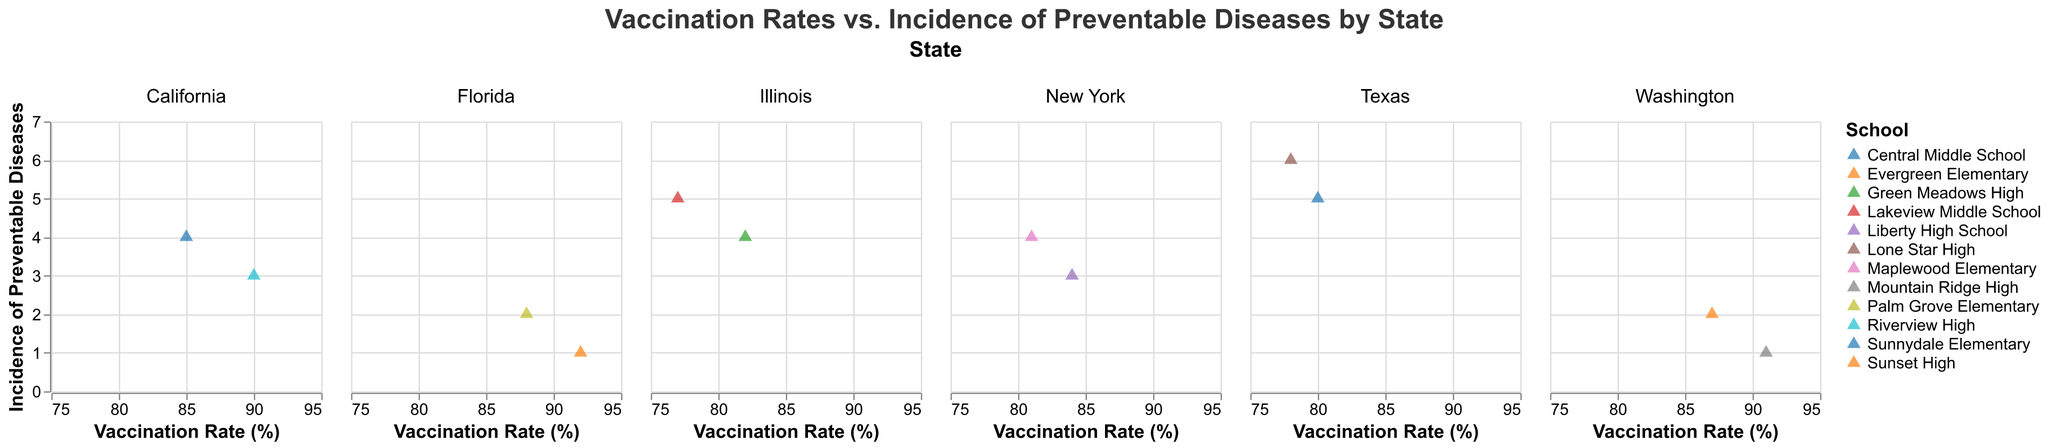What is the title of the chart? The title is usually placed at the top of the chart. Here, you can see it directly under the subtitle bar.
Answer: Vaccination Rates vs. Incidence of Preventable Diseases by State What are the axes labels? The x-axis and y-axis labels are placed at the bottom and the left side of the chart, respectively. The x-axis is labeled "Vaccination Rate (%)" and the y-axis is labeled "Incidence of Preventable Diseases".
Answer: Vaccination Rate (%) and Incidence of Preventable Diseases Which school in California has the highest vaccination rate? Look at the subplot for California and find the data point with the highest x-value (Vaccination Rate). The school associated with this point is Riverview High, with a vaccination rate of 90%.
Answer: Riverview High Compare the incidence of preventable diseases in Evergreen Elementary and Mountain Ridge High in Washington. In the Washington subplot, locate the points for Evergreen Elementary and Mountain Ridge High. Mountain Ridge High has an incidence value of 1 while Evergreen Elementary has an incidence value of 2.
Answer: Mountain Ridge High has fewer preventable diseases What trend can you observe between vaccination rates and incidences of preventable diseases? Generally, higher vaccination rates are associated with lower incidences of preventable diseases, as observed by the downward trend of points within each state subplot.
Answer: Higher vaccination rates reduce incidences Which State has the school with the lowest incidence of preventable diseases but not the highest vaccination rate? Identify all points with incidence of 1. These points are in Florida (Sunset High) and Washington (Mountain Ridge High). Among these states, Sunset High does not have the highest vaccination rate compared to Mountain Ridge High.
Answer: Florida (Sunset High) What is the average vaccination rate for schools in New York? Identify the x-values (Vaccination Rate) for both points in New York. Those are 81 for Maplewood Elementary and 84 for Liberty High School. Calculate the average (81+84)/2.
Answer: 82.5 Which school in Texas has the higher incidence of preventable diseases, and what is the difference? Locate the Texas subplot, find the y-values (Incidence of Preventable Diseases) for both schools. Central Middle School has an incidence of 5 and Lone Star High has 6. The difference is 6 - 5 = 1.
Answer: Lone Star High with a difference of 1 Is there a state where all schools have an incidence of preventable diseases of 2 or less? Look at each state subplot and verify that all points have y-values of 2 or less. Only Florida and Washington have schools with incidences of 2 or less.
Answer: Yes, Florida and Washington 